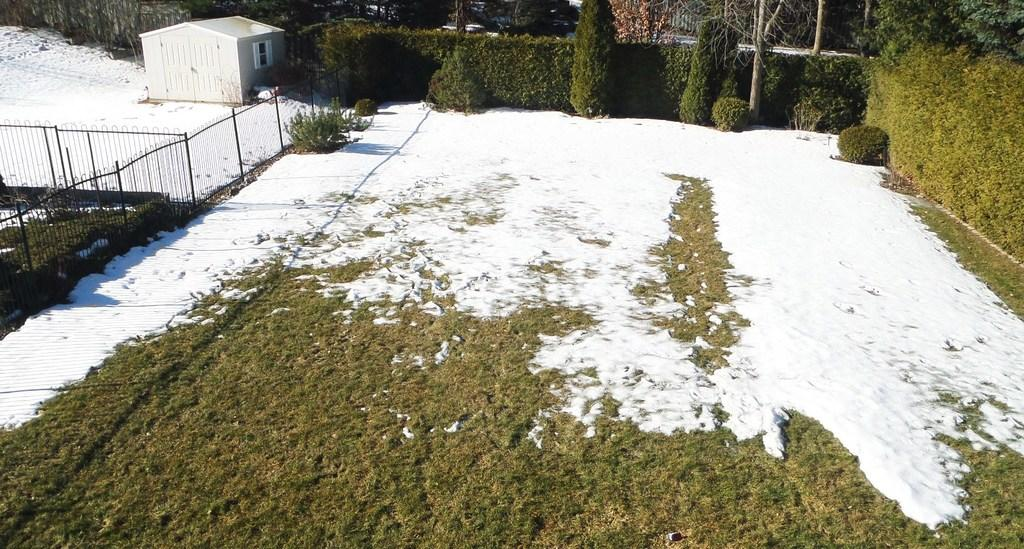What type of vegetation is present in the image? There is grass and snow in the image. What can be seen on the left side of the image? There is fencing on the left side of the image. What is visible in the background of the image? There are trees and plants in the background of the image. What type of basin is used for washing hands in the image? There is no basin present in the image. What type of vacation is being depicted in the image? The image does not depict a vacation; it shows grass, snow, fencing, and vegetation in the background. 